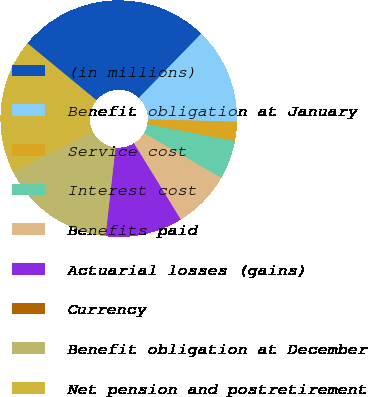Convert chart to OTSL. <chart><loc_0><loc_0><loc_500><loc_500><pie_chart><fcel>(in millions)<fcel>Benefit obligation at January<fcel>Service cost<fcel>Interest cost<fcel>Benefits paid<fcel>Actuarial losses (gains)<fcel>Currency<fcel>Benefit obligation at December<fcel>Net pension and postretirement<nl><fcel>26.28%<fcel>13.15%<fcel>2.65%<fcel>5.28%<fcel>7.9%<fcel>10.53%<fcel>0.03%<fcel>15.78%<fcel>18.4%<nl></chart> 